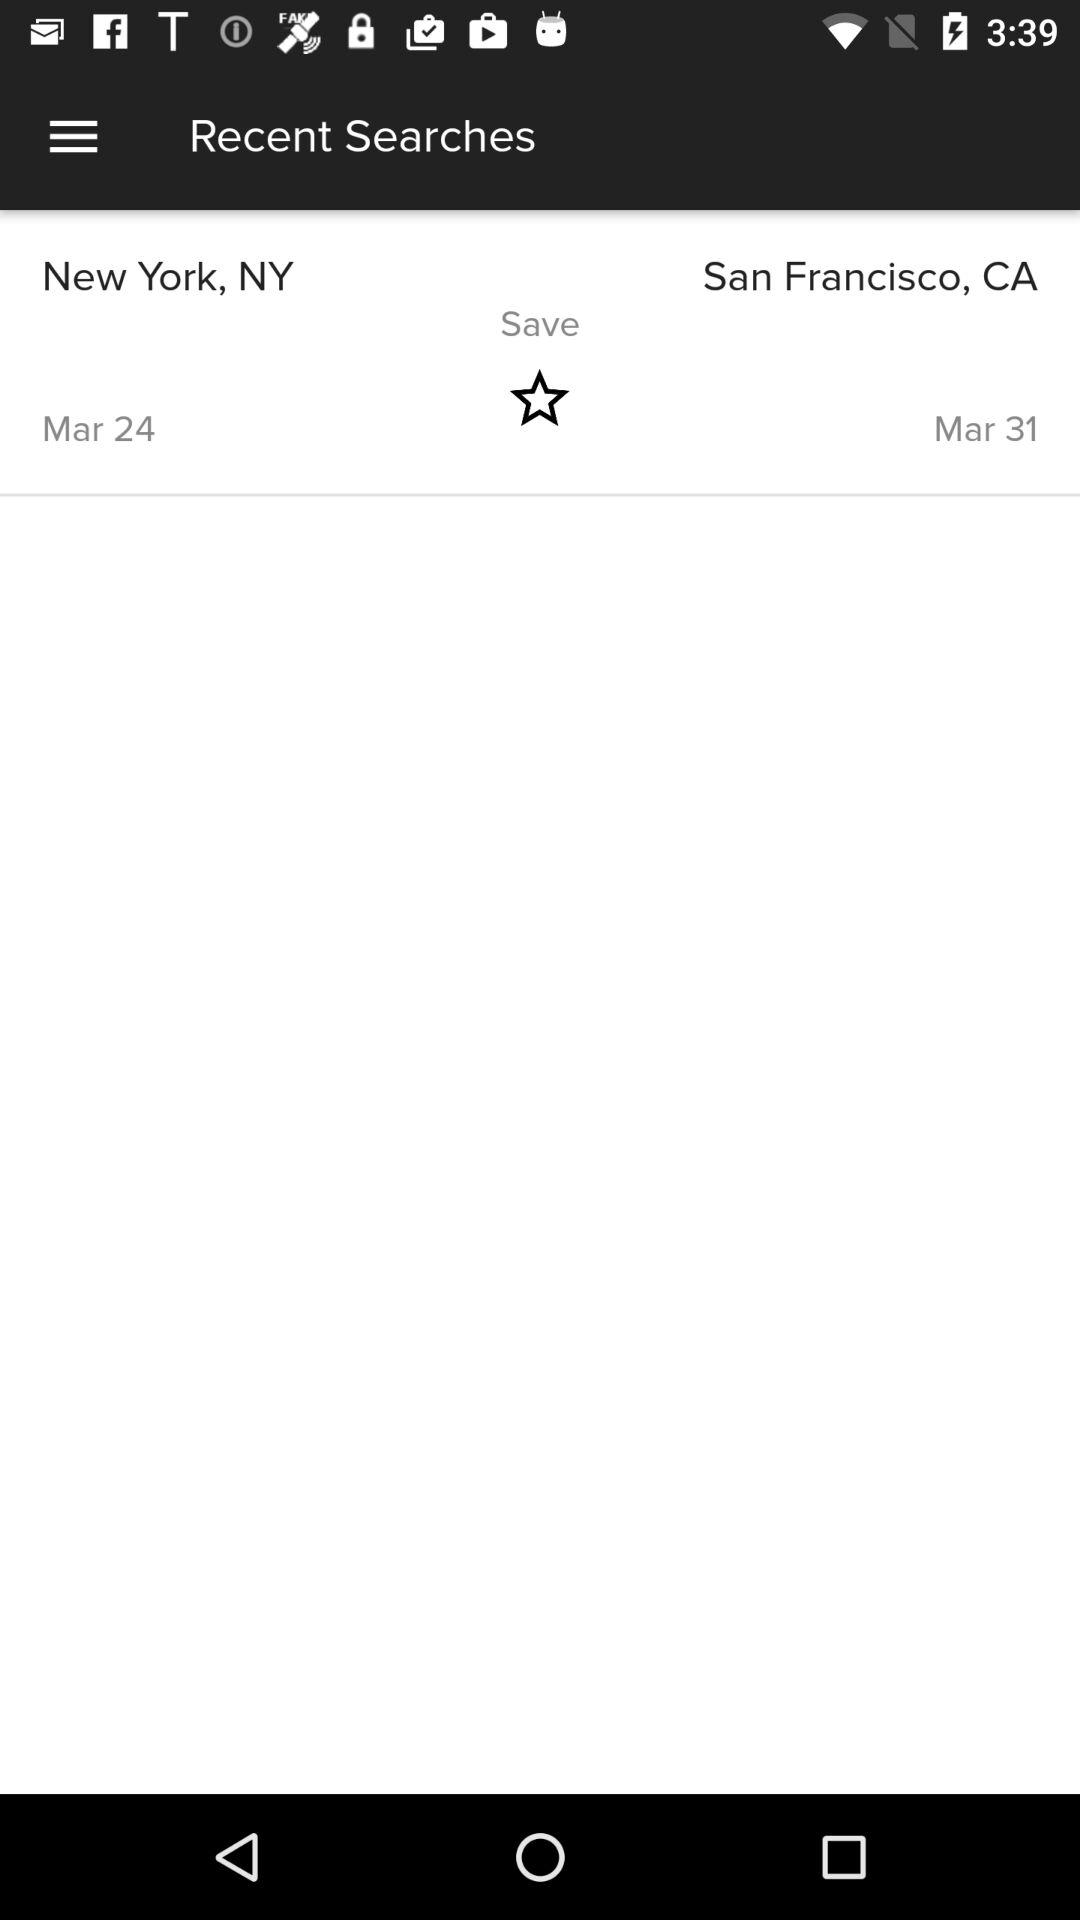What is the start date? The start date is March 24. 